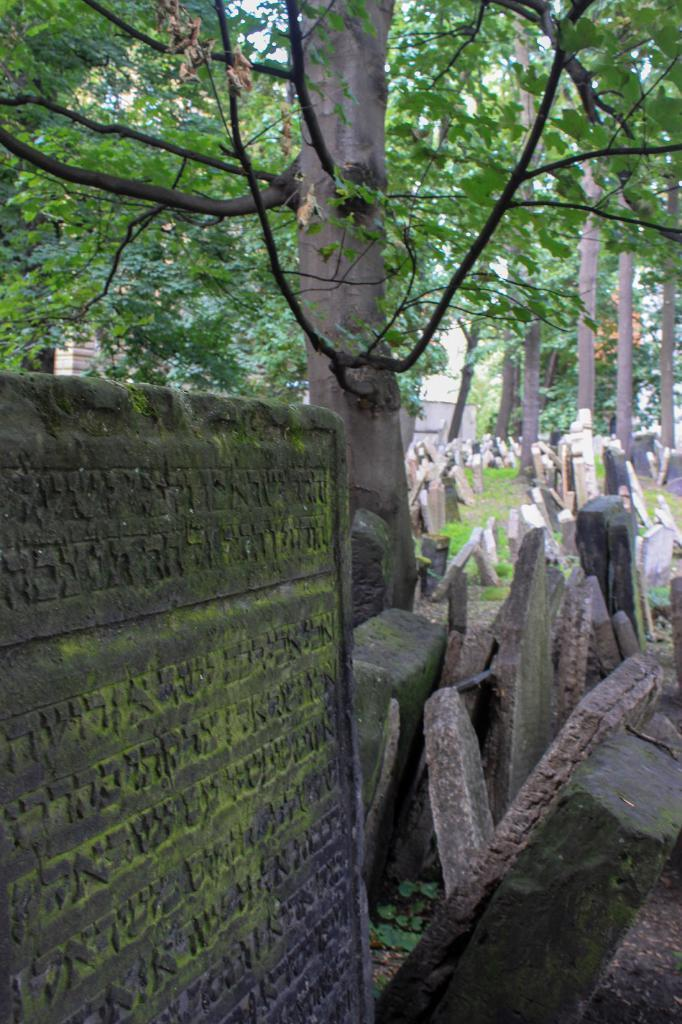What type of location is depicted in the image? The image contains cemeteries. What is the primary architectural feature in the image? There is a wall in the image. What type of natural elements are present in the image? There are trees and plants in the image. What type of bulb is being used for teaching in the image? There is no teaching or bulb present in the image. 